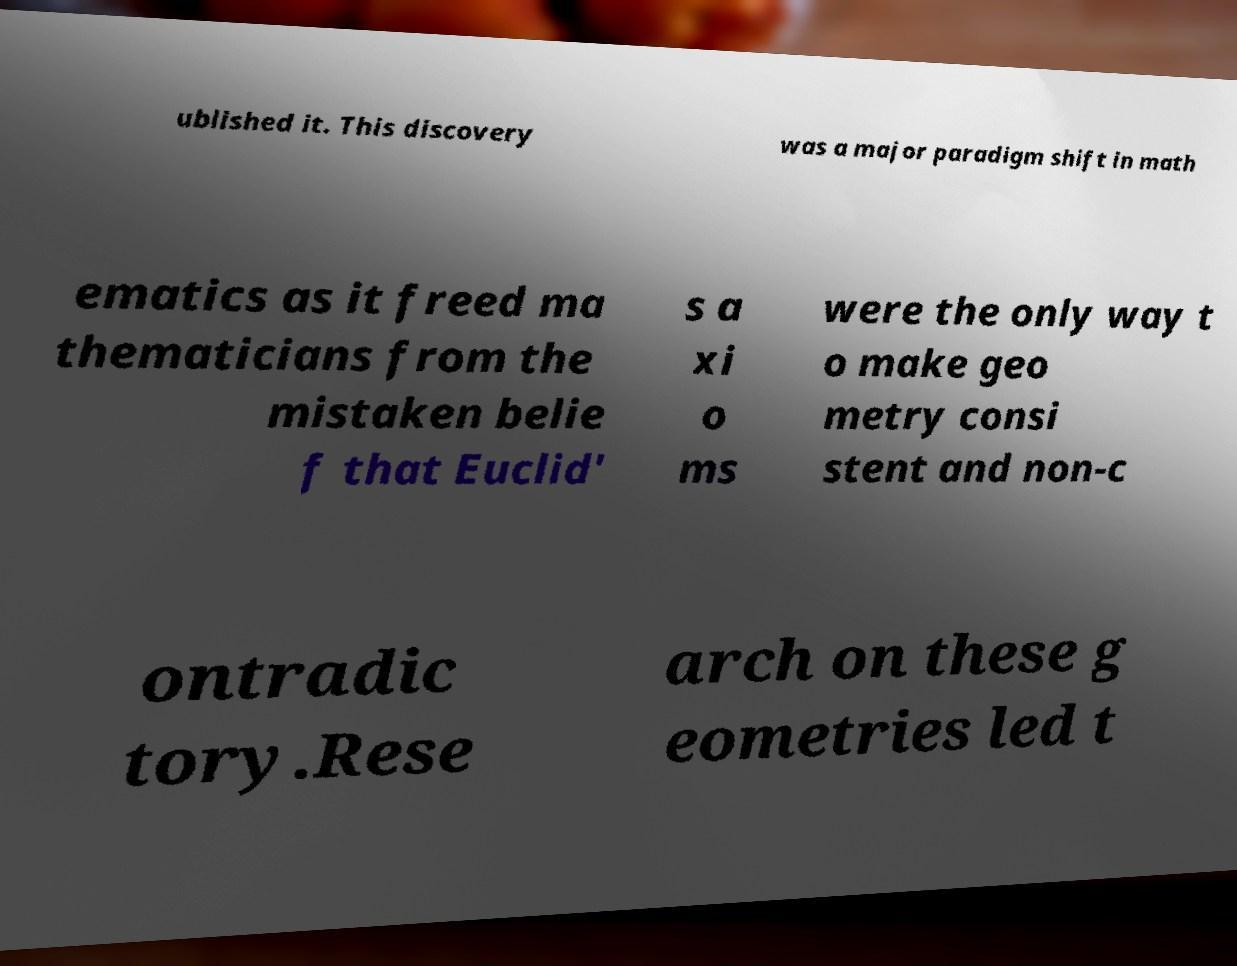Could you extract and type out the text from this image? ublished it. This discovery was a major paradigm shift in math ematics as it freed ma thematicians from the mistaken belie f that Euclid' s a xi o ms were the only way t o make geo metry consi stent and non-c ontradic tory.Rese arch on these g eometries led t 